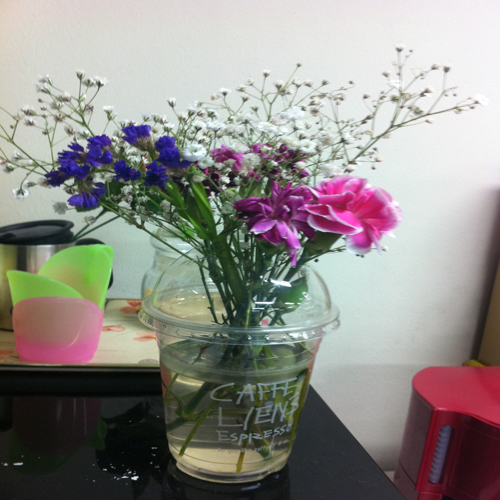Do the colors appear natural? Yes, the colors do appear natural. The flowers display a variety of hues such as vibrant pink and rich purple which are typical of fresh flowers, while the white baby's breath complements them with a more subtle tone. The green of the stems and leaves further contributes to the natural and lively color palette. 